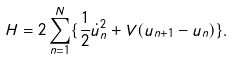Convert formula to latex. <formula><loc_0><loc_0><loc_500><loc_500>H = 2 \sum _ { n = 1 } ^ { N } \{ \frac { 1 } { 2 } \dot { u } ^ { 2 } _ { n } + V ( u _ { n + 1 } - u _ { n } ) \} .</formula> 